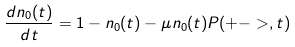Convert formula to latex. <formula><loc_0><loc_0><loc_500><loc_500>\frac { d n _ { 0 } ( t ) } { d t } = 1 - n _ { 0 } ( t ) - \mu n _ { 0 } ( t ) P ( + - > , t )</formula> 